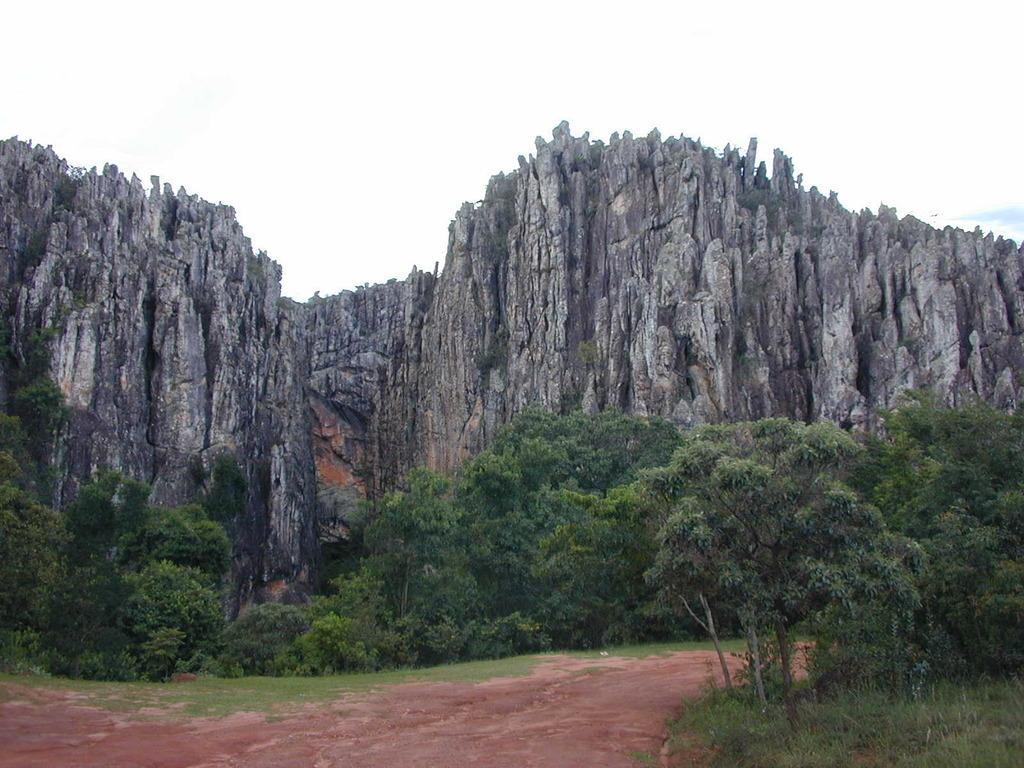Describe this image in one or two sentences. In this image, we can see a rock mountains. At the bottom, we can see so many trees, plants, grass, walk way. 